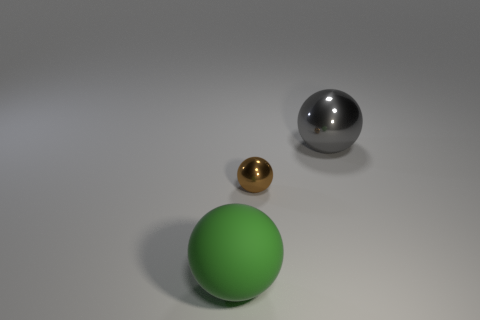Are there any other things that have the same size as the brown ball?
Your answer should be compact. No. Are there any other brown objects of the same shape as the big matte thing?
Give a very brief answer. Yes. How many other objects are there of the same shape as the gray metallic thing?
Keep it short and to the point. 2. Is there any other thing that has the same material as the big green object?
Offer a very short reply. No. There is another brown thing that is the same shape as the large metal object; what material is it?
Give a very brief answer. Metal. What number of tiny objects are brown metallic balls or yellow matte blocks?
Your response must be concise. 1. Are there fewer brown shiny spheres behind the tiny sphere than large spheres that are left of the big gray shiny ball?
Your answer should be very brief. Yes. What number of things are either small gray metal blocks or big objects?
Your answer should be very brief. 2. There is a small brown object; how many metallic balls are left of it?
Provide a short and direct response. 0. Do the tiny sphere and the big rubber thing have the same color?
Your response must be concise. No. 